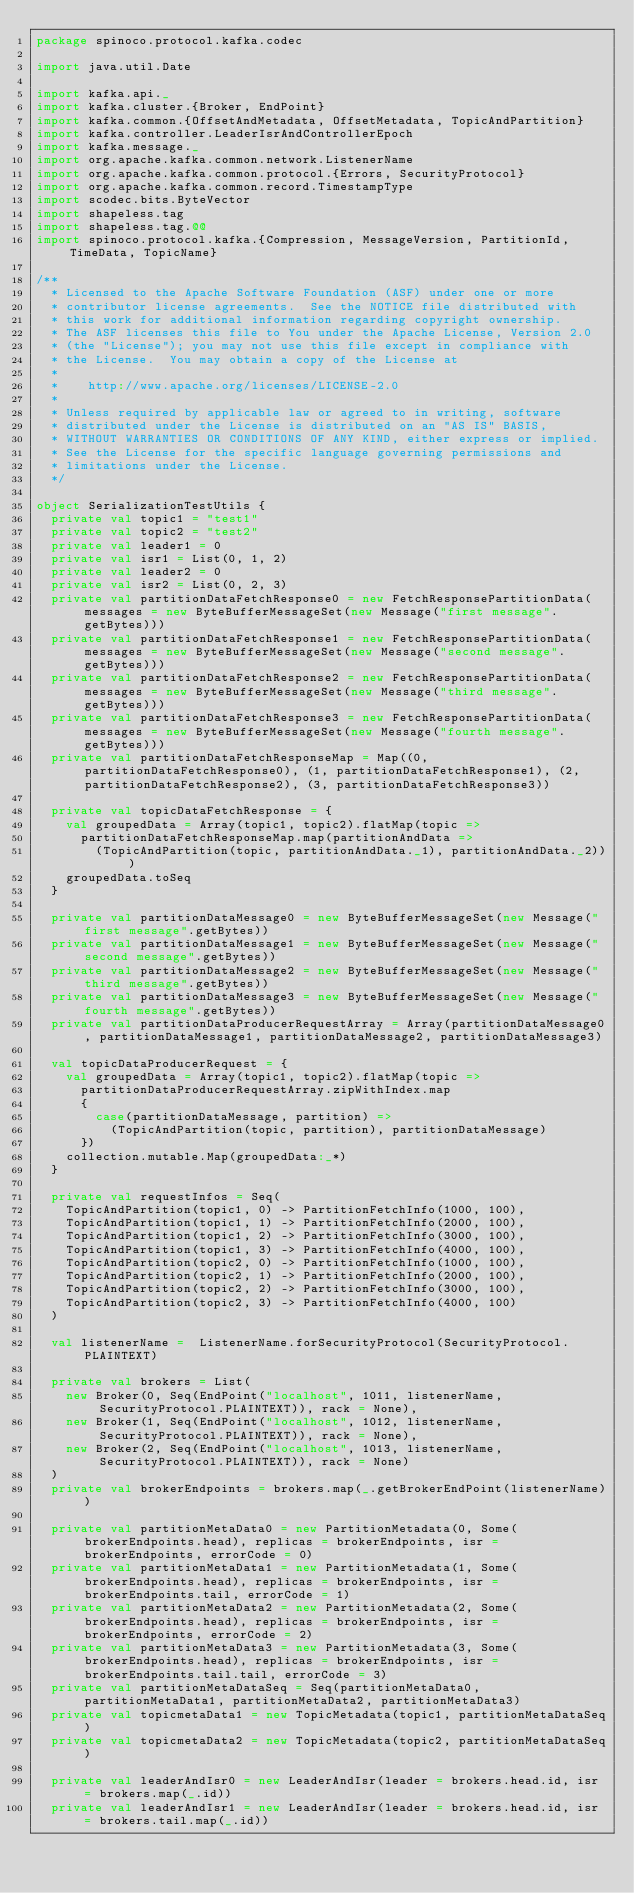Convert code to text. <code><loc_0><loc_0><loc_500><loc_500><_Scala_>package spinoco.protocol.kafka.codec

import java.util.Date

import kafka.api._
import kafka.cluster.{Broker, EndPoint}
import kafka.common.{OffsetAndMetadata, OffsetMetadata, TopicAndPartition}
import kafka.controller.LeaderIsrAndControllerEpoch
import kafka.message._
import org.apache.kafka.common.network.ListenerName
import org.apache.kafka.common.protocol.{Errors, SecurityProtocol}
import org.apache.kafka.common.record.TimestampType
import scodec.bits.ByteVector
import shapeless.tag
import shapeless.tag.@@
import spinoco.protocol.kafka.{Compression, MessageVersion, PartitionId, TimeData, TopicName}

/**
  * Licensed to the Apache Software Foundation (ASF) under one or more
  * contributor license agreements.  See the NOTICE file distributed with
  * this work for additional information regarding copyright ownership.
  * The ASF licenses this file to You under the Apache License, Version 2.0
  * (the "License"); you may not use this file except in compliance with
  * the License.  You may obtain a copy of the License at
  *
  *    http://www.apache.org/licenses/LICENSE-2.0
  *
  * Unless required by applicable law or agreed to in writing, software
  * distributed under the License is distributed on an "AS IS" BASIS,
  * WITHOUT WARRANTIES OR CONDITIONS OF ANY KIND, either express or implied.
  * See the License for the specific language governing permissions and
  * limitations under the License.
  */

object SerializationTestUtils {
  private val topic1 = "test1"
  private val topic2 = "test2"
  private val leader1 = 0
  private val isr1 = List(0, 1, 2)
  private val leader2 = 0
  private val isr2 = List(0, 2, 3)
  private val partitionDataFetchResponse0 = new FetchResponsePartitionData(messages = new ByteBufferMessageSet(new Message("first message".getBytes)))
  private val partitionDataFetchResponse1 = new FetchResponsePartitionData(messages = new ByteBufferMessageSet(new Message("second message".getBytes)))
  private val partitionDataFetchResponse2 = new FetchResponsePartitionData(messages = new ByteBufferMessageSet(new Message("third message".getBytes)))
  private val partitionDataFetchResponse3 = new FetchResponsePartitionData(messages = new ByteBufferMessageSet(new Message("fourth message".getBytes)))
  private val partitionDataFetchResponseMap = Map((0, partitionDataFetchResponse0), (1, partitionDataFetchResponse1), (2, partitionDataFetchResponse2), (3, partitionDataFetchResponse3))

  private val topicDataFetchResponse = {
    val groupedData = Array(topic1, topic2).flatMap(topic =>
      partitionDataFetchResponseMap.map(partitionAndData =>
        (TopicAndPartition(topic, partitionAndData._1), partitionAndData._2)))
    groupedData.toSeq
  }

  private val partitionDataMessage0 = new ByteBufferMessageSet(new Message("first message".getBytes))
  private val partitionDataMessage1 = new ByteBufferMessageSet(new Message("second message".getBytes))
  private val partitionDataMessage2 = new ByteBufferMessageSet(new Message("third message".getBytes))
  private val partitionDataMessage3 = new ByteBufferMessageSet(new Message("fourth message".getBytes))
  private val partitionDataProducerRequestArray = Array(partitionDataMessage0, partitionDataMessage1, partitionDataMessage2, partitionDataMessage3)

  val topicDataProducerRequest = {
    val groupedData = Array(topic1, topic2).flatMap(topic =>
      partitionDataProducerRequestArray.zipWithIndex.map
      {
        case(partitionDataMessage, partition) =>
          (TopicAndPartition(topic, partition), partitionDataMessage)
      })
    collection.mutable.Map(groupedData:_*)
  }

  private val requestInfos = Seq(
    TopicAndPartition(topic1, 0) -> PartitionFetchInfo(1000, 100),
    TopicAndPartition(topic1, 1) -> PartitionFetchInfo(2000, 100),
    TopicAndPartition(topic1, 2) -> PartitionFetchInfo(3000, 100),
    TopicAndPartition(topic1, 3) -> PartitionFetchInfo(4000, 100),
    TopicAndPartition(topic2, 0) -> PartitionFetchInfo(1000, 100),
    TopicAndPartition(topic2, 1) -> PartitionFetchInfo(2000, 100),
    TopicAndPartition(topic2, 2) -> PartitionFetchInfo(3000, 100),
    TopicAndPartition(topic2, 3) -> PartitionFetchInfo(4000, 100)
  )

  val listenerName =  ListenerName.forSecurityProtocol(SecurityProtocol.PLAINTEXT)

  private val brokers = List(
    new Broker(0, Seq(EndPoint("localhost", 1011, listenerName,  SecurityProtocol.PLAINTEXT)), rack = None),
    new Broker(1, Seq(EndPoint("localhost", 1012, listenerName, SecurityProtocol.PLAINTEXT)), rack = None),
    new Broker(2, Seq(EndPoint("localhost", 1013, listenerName, SecurityProtocol.PLAINTEXT)), rack = None)
  )
  private val brokerEndpoints = brokers.map(_.getBrokerEndPoint(listenerName))

  private val partitionMetaData0 = new PartitionMetadata(0, Some(brokerEndpoints.head), replicas = brokerEndpoints, isr = brokerEndpoints, errorCode = 0)
  private val partitionMetaData1 = new PartitionMetadata(1, Some(brokerEndpoints.head), replicas = brokerEndpoints, isr = brokerEndpoints.tail, errorCode = 1)
  private val partitionMetaData2 = new PartitionMetadata(2, Some(brokerEndpoints.head), replicas = brokerEndpoints, isr = brokerEndpoints, errorCode = 2)
  private val partitionMetaData3 = new PartitionMetadata(3, Some(brokerEndpoints.head), replicas = brokerEndpoints, isr = brokerEndpoints.tail.tail, errorCode = 3)
  private val partitionMetaDataSeq = Seq(partitionMetaData0, partitionMetaData1, partitionMetaData2, partitionMetaData3)
  private val topicmetaData1 = new TopicMetadata(topic1, partitionMetaDataSeq)
  private val topicmetaData2 = new TopicMetadata(topic2, partitionMetaDataSeq)

  private val leaderAndIsr0 = new LeaderAndIsr(leader = brokers.head.id, isr = brokers.map(_.id))
  private val leaderAndIsr1 = new LeaderAndIsr(leader = brokers.head.id, isr = brokers.tail.map(_.id))</code> 